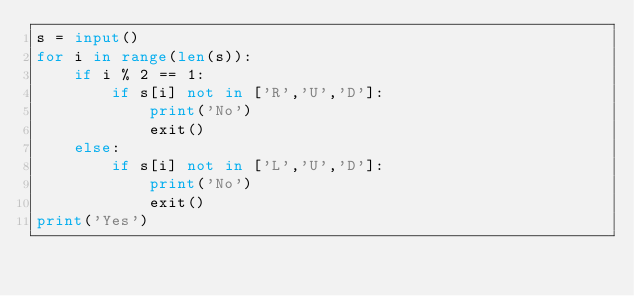Convert code to text. <code><loc_0><loc_0><loc_500><loc_500><_Python_>s = input()
for i in range(len(s)):
    if i % 2 == 1:
        if s[i] not in ['R','U','D']:
            print('No')
            exit()
    else:
        if s[i] not in ['L','U','D']:
            print('No')
            exit()        
print('Yes')</code> 